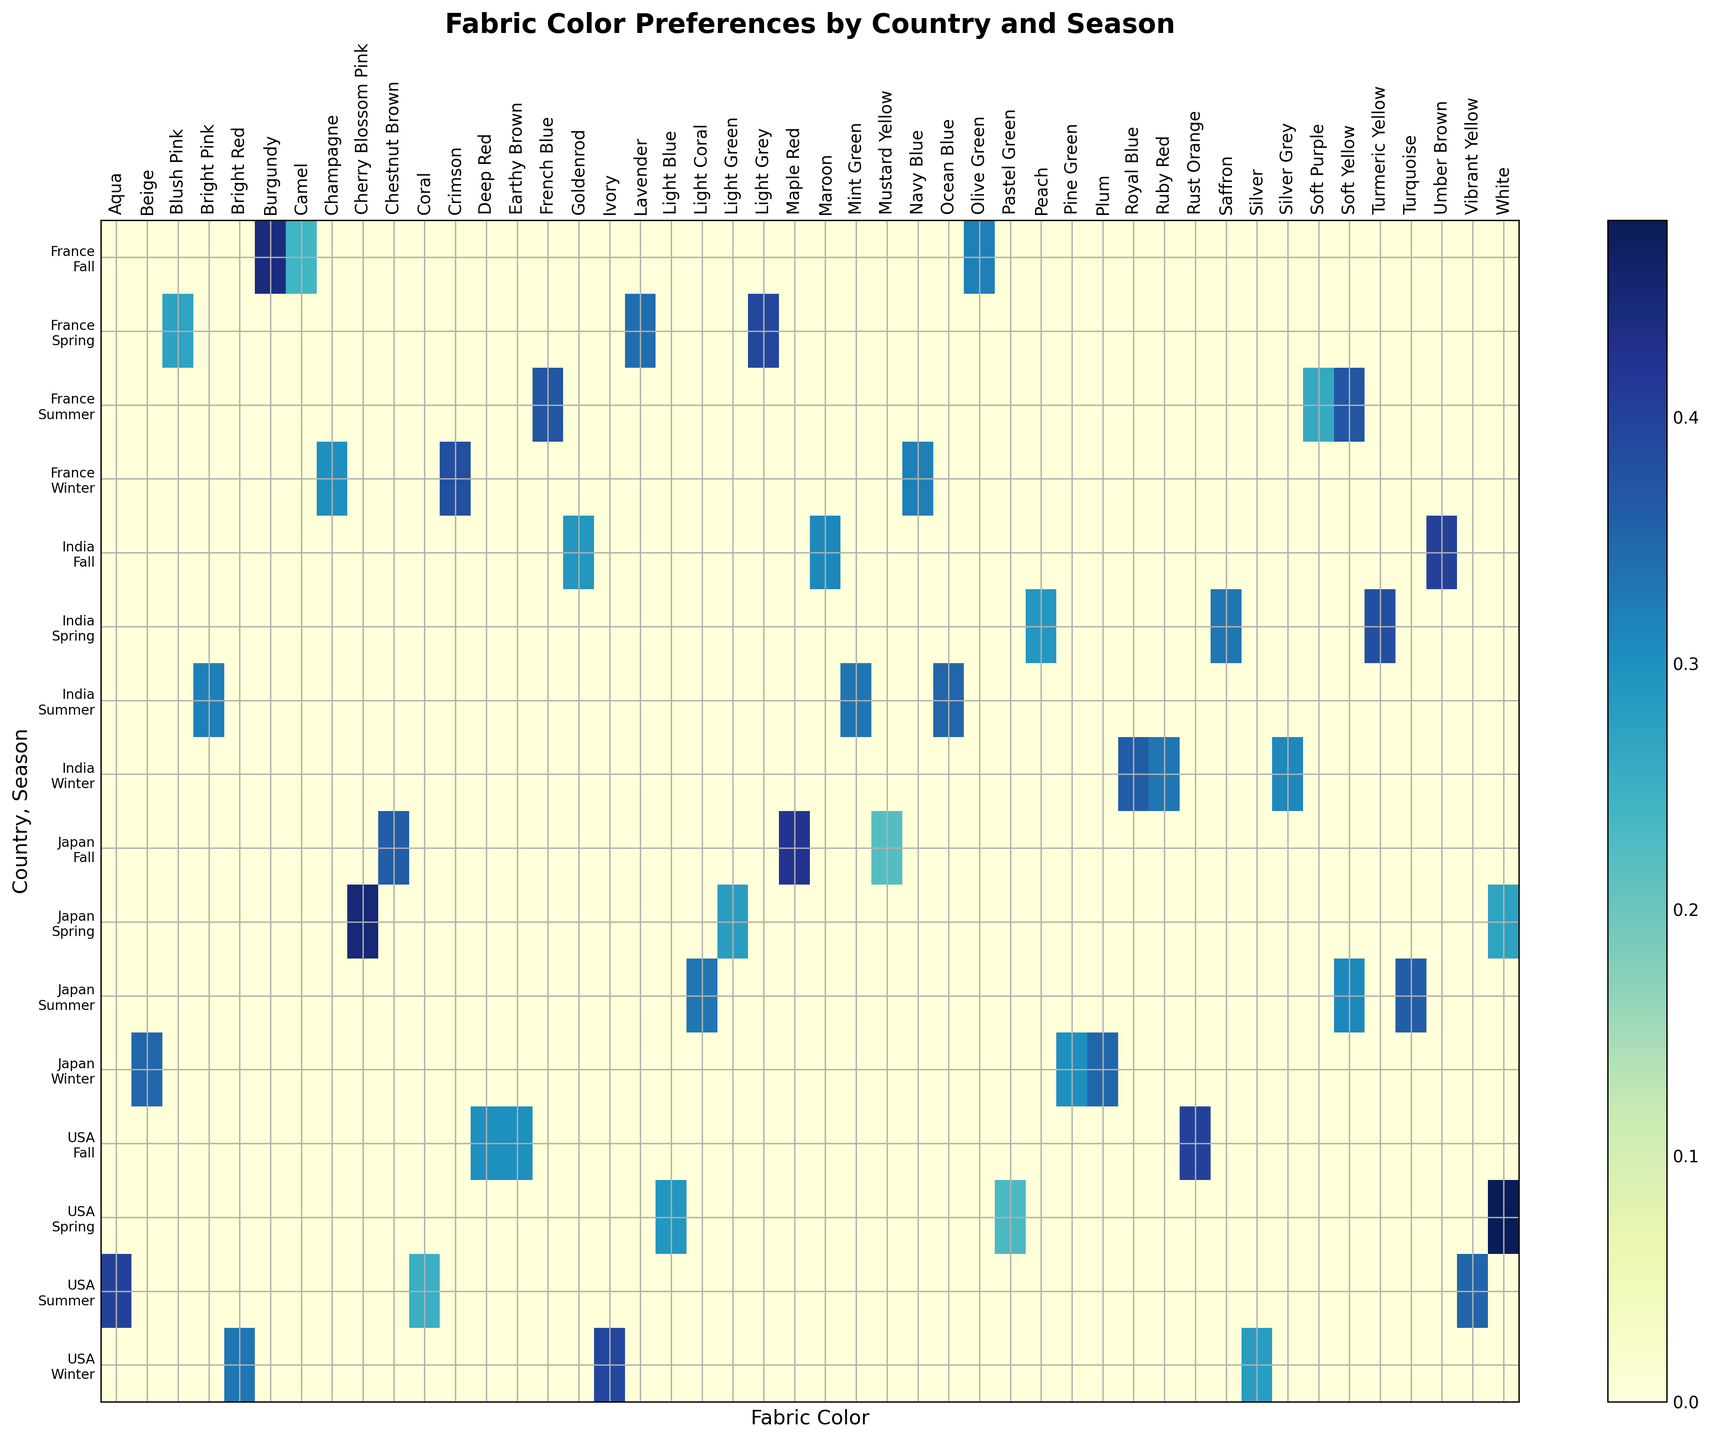Which country has the highest preference for Olive Green during Fall? Look at the preference values for Olive Green in Fall across all countries. Compare the values: USA (0.00), France (0.32), Japan (0.00), India (0.00).
Answer: France What is the average preference for Light Grey in Spring across all countries? Identify the preference values for Light Grey in Spring for each country. USA doesn't have it, but France has 0.39, Japan doesn't, and India doesn't. As only France has this preference, the average is 0.39.
Answer: 0.39 What is the sum of preference values for all colors in Japan during Winter? Find the preference values for colors in Japan during Winter: Plum (0.35), Pine Green (0.30), and Beige (0.35). Sum these values: 0.35 + 0.30 + 0.35 = 1.00.
Answer: 1.00 Which season in France sees the highest preference for any color, and which color is it? Look at the highest preference values in each season in France: Spring (Light Grey: 0.39), Summer (French Blue: 0.37), Fall (Burgundy: 0.44), Winter (Crimson: 0.38). Burgundy in Fall has the highest preference among them.
Answer: Fall, Burgundy Is Light Blue in USA during Spring more or less preferred than Saffron in India during Spring? Locate the preference for Light Blue in USA during Spring (0.29) and compare it to the preference for Saffron in India during Spring (0.33). Light Blue is less preferred.
Answer: Less How does the preference for Champagne in France during Winter compare with Ruby Red in India during Winter? Identify the preferences: Champagne in France during Winter is 0.30, and Ruby Red in India during Winter is 0.33. Compare these values.
Answer: Ruby Red in India during Winter is preferred by 0.03 more What is the visual color score range difference between the highest and the lowest preferences for colors in USA during Fall? Look at the preference values: Earthy Brown (0.30), Rust Orange (0.40), Deep Red (0.30). The highest is 0.40 and the lowest is 0.30. The range is 0.40 - 0.30 = 0.10.
Answer: 0.10 Which country's Spring season shows the most varied color preferences, and what is the standard deviation for that season? Calculate the preference spread for each country during Spring: USA (0.23 to 0.48), France (0.27 to 0.39), Japan (0.27 to 0.45), India (0.29 to 0.38). Then calculate SD for the most varied (Japan). SD = sqrt((0.45-Avg)^2 + (0.28-Avg)^2 + (0.27-Avg)^2). Avg = (0.45+0.28+0.27)/3 = 0.33. SD = sqrt((0.12)^2 + (0.05)^2 + (0.06)^2)/2 = 0.078
Answer: Japan, ~0.078 